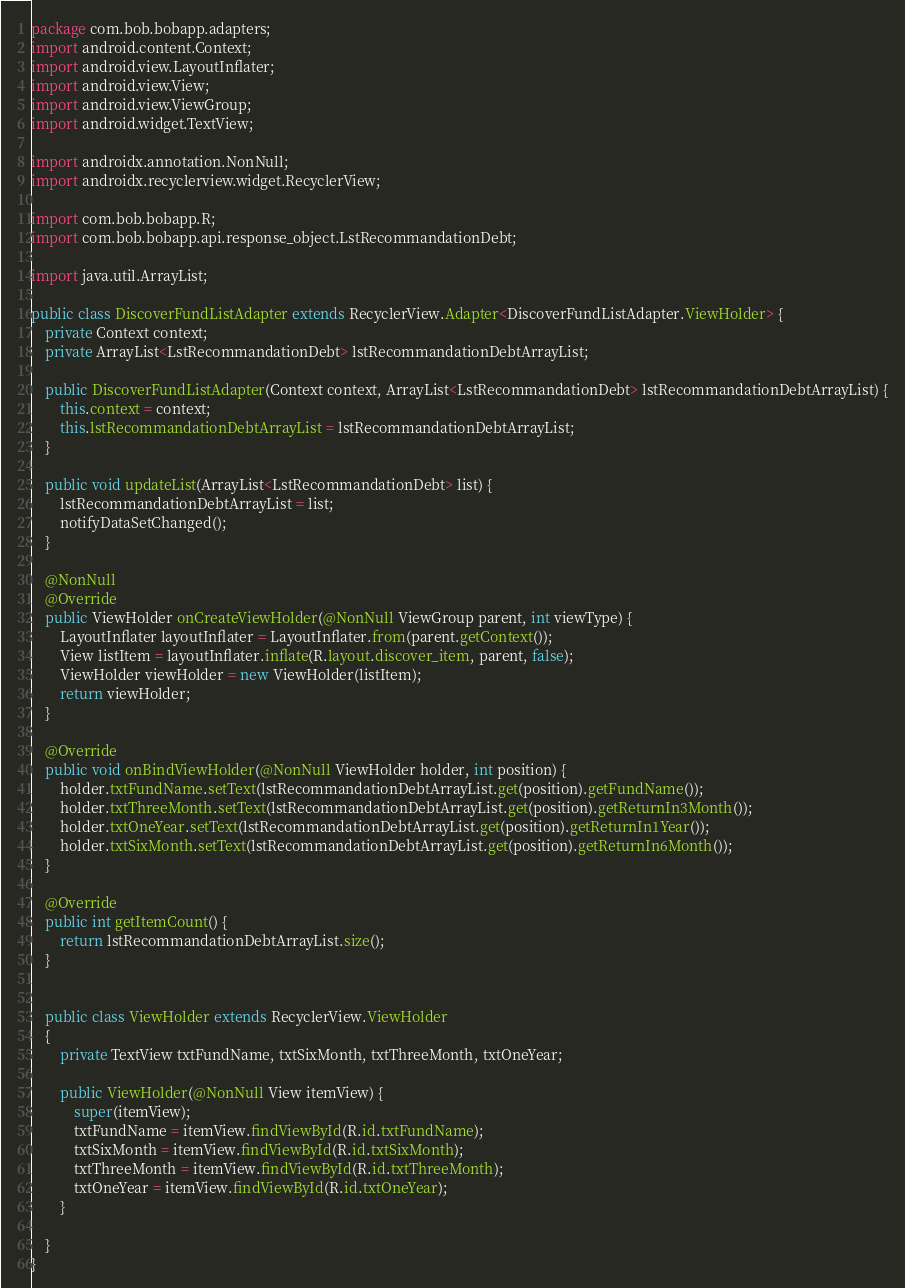Convert code to text. <code><loc_0><loc_0><loc_500><loc_500><_Java_>package com.bob.bobapp.adapters;
import android.content.Context;
import android.view.LayoutInflater;
import android.view.View;
import android.view.ViewGroup;
import android.widget.TextView;

import androidx.annotation.NonNull;
import androidx.recyclerview.widget.RecyclerView;

import com.bob.bobapp.R;
import com.bob.bobapp.api.response_object.LstRecommandationDebt;

import java.util.ArrayList;

public class DiscoverFundListAdapter extends RecyclerView.Adapter<DiscoverFundListAdapter.ViewHolder> {
    private Context context;
    private ArrayList<LstRecommandationDebt> lstRecommandationDebtArrayList;

    public DiscoverFundListAdapter(Context context, ArrayList<LstRecommandationDebt> lstRecommandationDebtArrayList) {
        this.context = context;
        this.lstRecommandationDebtArrayList = lstRecommandationDebtArrayList;
    }

    public void updateList(ArrayList<LstRecommandationDebt> list) {
        lstRecommandationDebtArrayList = list;
        notifyDataSetChanged();
    }

    @NonNull
    @Override
    public ViewHolder onCreateViewHolder(@NonNull ViewGroup parent, int viewType) {
        LayoutInflater layoutInflater = LayoutInflater.from(parent.getContext());
        View listItem = layoutInflater.inflate(R.layout.discover_item, parent, false);
        ViewHolder viewHolder = new ViewHolder(listItem);
        return viewHolder;
    }

    @Override
    public void onBindViewHolder(@NonNull ViewHolder holder, int position) {
        holder.txtFundName.setText(lstRecommandationDebtArrayList.get(position).getFundName());
        holder.txtThreeMonth.setText(lstRecommandationDebtArrayList.get(position).getReturnIn3Month());
        holder.txtOneYear.setText(lstRecommandationDebtArrayList.get(position).getReturnIn1Year());
        holder.txtSixMonth.setText(lstRecommandationDebtArrayList.get(position).getReturnIn6Month());
    }

    @Override
    public int getItemCount() {
        return lstRecommandationDebtArrayList.size();
    }


    public class ViewHolder extends RecyclerView.ViewHolder
    {
        private TextView txtFundName, txtSixMonth, txtThreeMonth, txtOneYear;

        public ViewHolder(@NonNull View itemView) {
            super(itemView);
            txtFundName = itemView.findViewById(R.id.txtFundName);
            txtSixMonth = itemView.findViewById(R.id.txtSixMonth);
            txtThreeMonth = itemView.findViewById(R.id.txtThreeMonth);
            txtOneYear = itemView.findViewById(R.id.txtOneYear);
        }

    }
}
</code> 